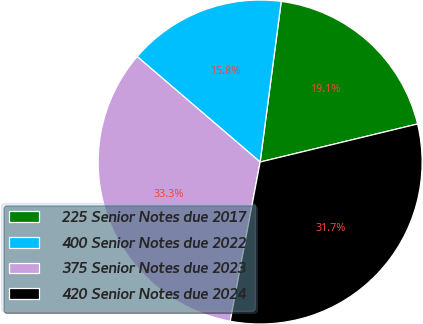Convert chart to OTSL. <chart><loc_0><loc_0><loc_500><loc_500><pie_chart><fcel>225 Senior Notes due 2017<fcel>400 Senior Notes due 2022<fcel>375 Senior Notes due 2023<fcel>420 Senior Notes due 2024<nl><fcel>19.15%<fcel>15.8%<fcel>33.33%<fcel>31.73%<nl></chart> 